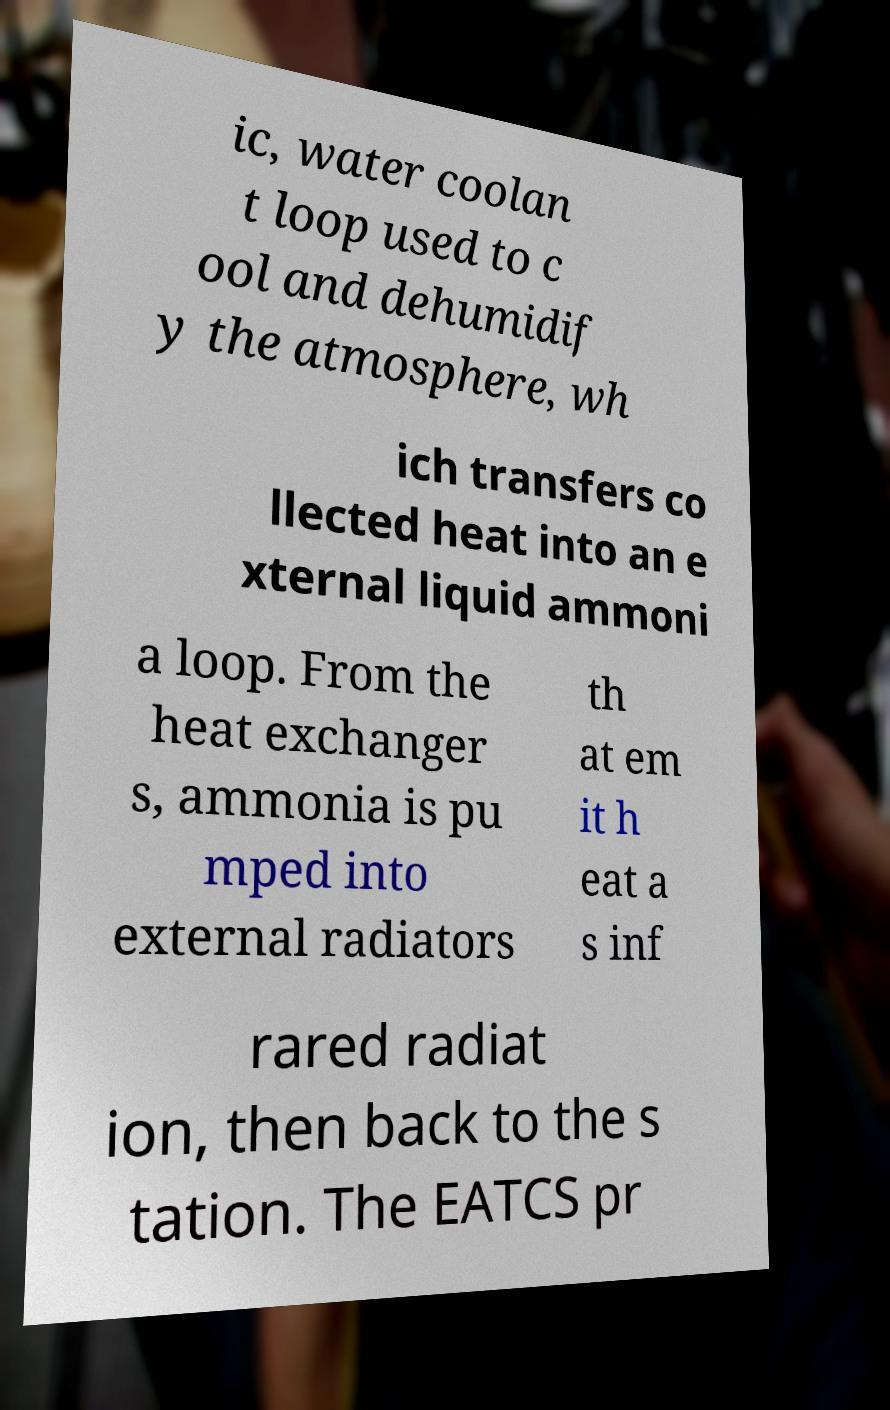Please identify and transcribe the text found in this image. ic, water coolan t loop used to c ool and dehumidif y the atmosphere, wh ich transfers co llected heat into an e xternal liquid ammoni a loop. From the heat exchanger s, ammonia is pu mped into external radiators th at em it h eat a s inf rared radiat ion, then back to the s tation. The EATCS pr 